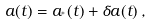<formula> <loc_0><loc_0><loc_500><loc_500>a ( t ) = a _ { ^ { * } } ( t ) + \delta a ( t ) \, ,</formula> 